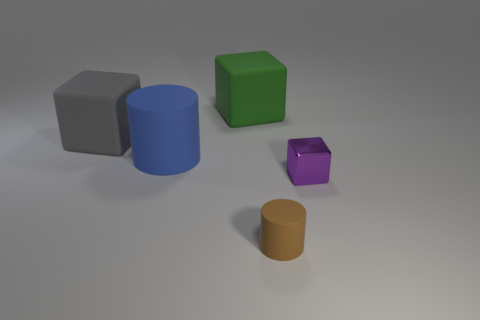What are the colors of the objects in the image, starting from the largest to the smallest? The colors of the objects from largest to smallest are blue, gray, green, purple, and orange. 